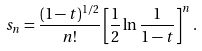Convert formula to latex. <formula><loc_0><loc_0><loc_500><loc_500>s _ { n } = \frac { ( 1 - t ) ^ { 1 / 2 } } { n ! } \left [ \frac { 1 } { 2 } \ln \frac { 1 } { 1 - t } \right ] ^ { n } .</formula> 